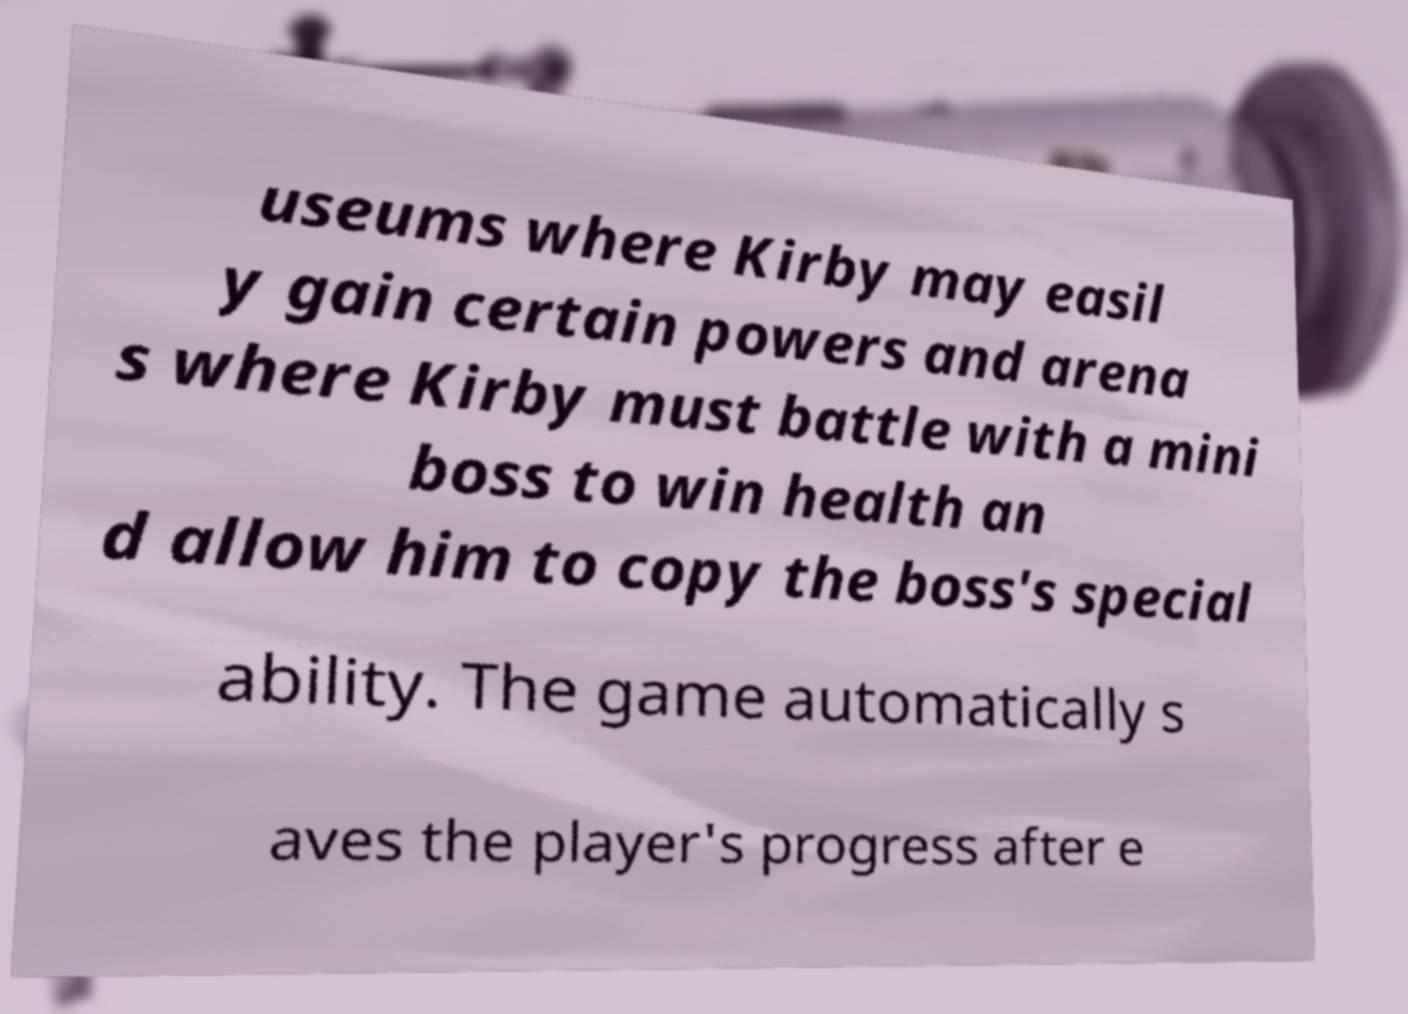Could you extract and type out the text from this image? useums where Kirby may easil y gain certain powers and arena s where Kirby must battle with a mini boss to win health an d allow him to copy the boss's special ability. The game automatically s aves the player's progress after e 